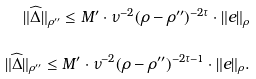Convert formula to latex. <formula><loc_0><loc_0><loc_500><loc_500>\| \widehat { \Delta } \| _ { \rho ^ { \prime \prime } } \leq M ^ { \prime } \cdot \nu ^ { - 2 } ( \rho - \rho ^ { \prime \prime } ) ^ { - 2 \tau } \cdot \| e \| _ { \rho } \\ \| \widehat { \Delta } \| _ { \rho ^ { \prime \prime } } \leq M ^ { \prime } \cdot \nu ^ { - 2 } ( \rho - \rho ^ { \prime \prime } ) ^ { - 2 \tau - 1 } \cdot \| e \| _ { \rho } . \\</formula> 